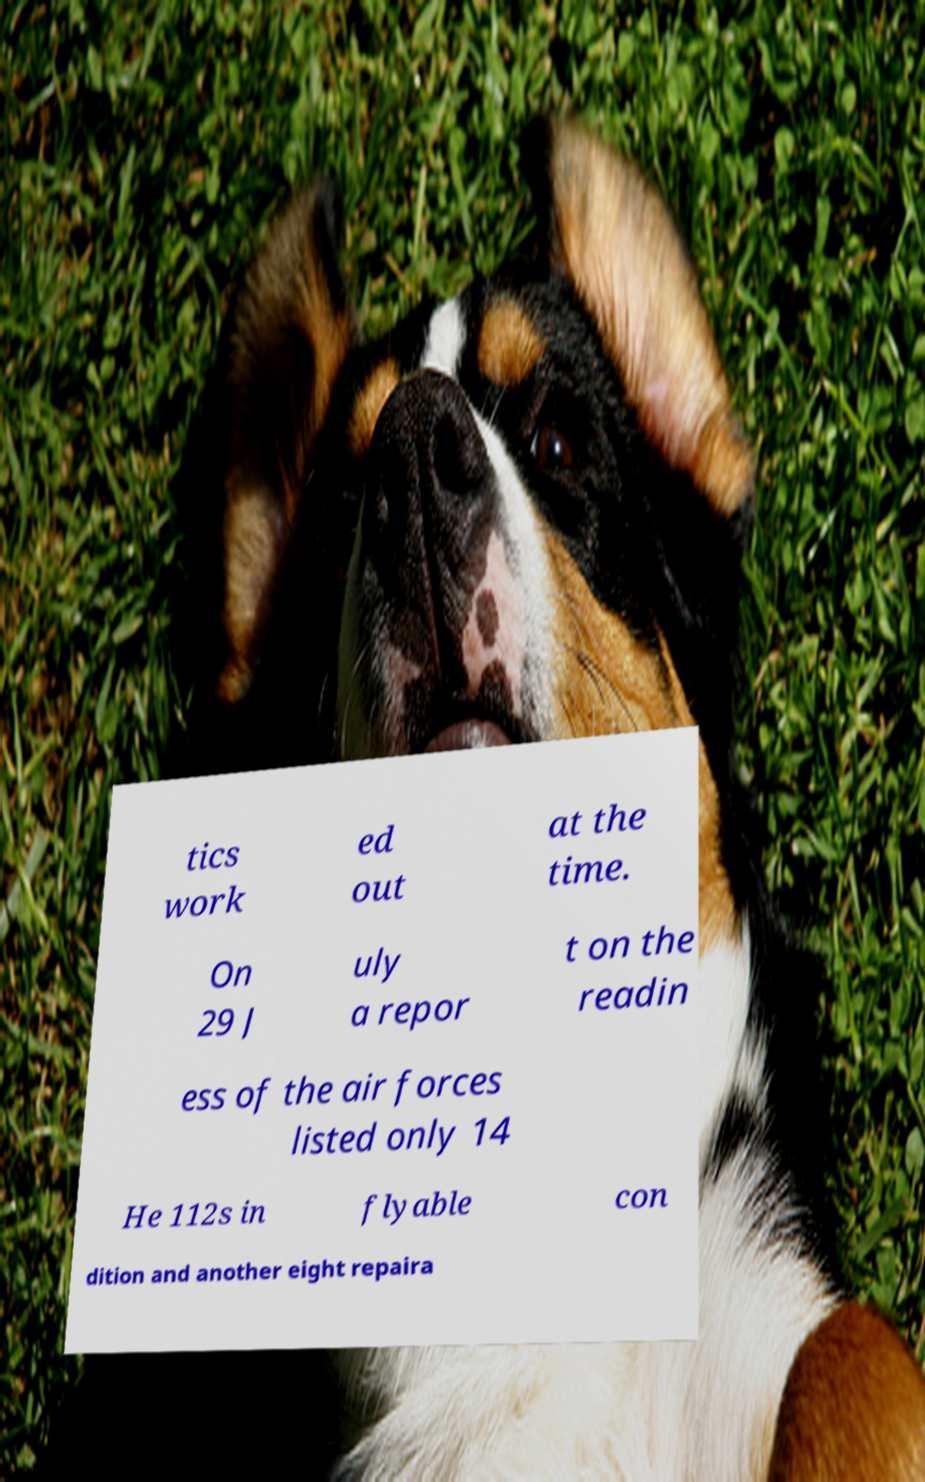Please read and relay the text visible in this image. What does it say? tics work ed out at the time. On 29 J uly a repor t on the readin ess of the air forces listed only 14 He 112s in flyable con dition and another eight repaira 